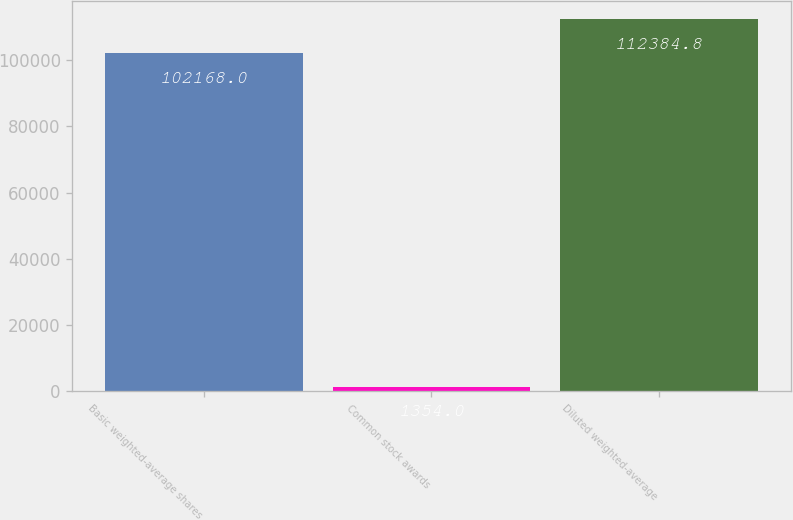<chart> <loc_0><loc_0><loc_500><loc_500><bar_chart><fcel>Basic weighted-average shares<fcel>Common stock awards<fcel>Diluted weighted-average<nl><fcel>102168<fcel>1354<fcel>112385<nl></chart> 